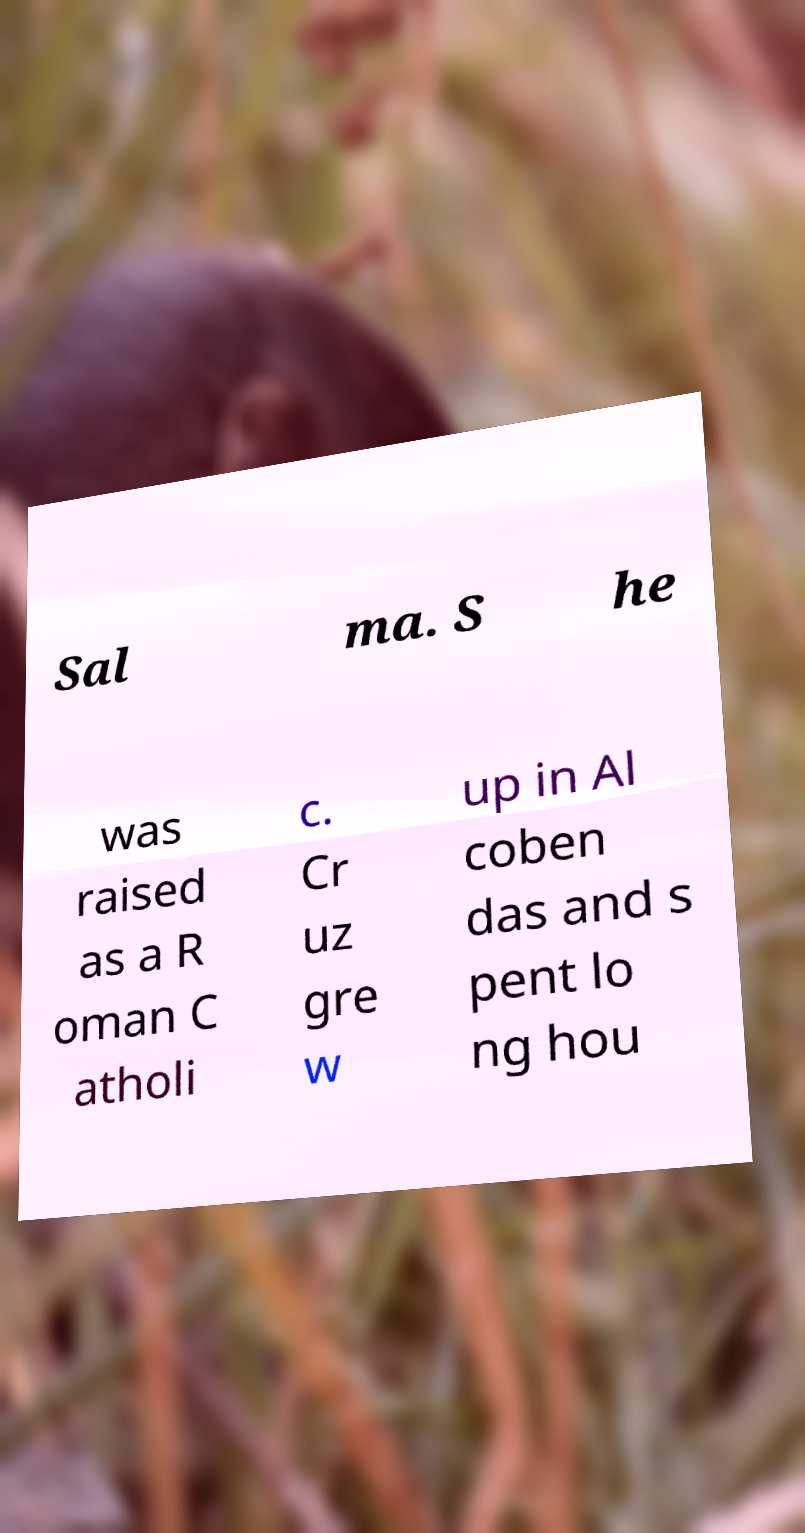For documentation purposes, I need the text within this image transcribed. Could you provide that? Sal ma. S he was raised as a R oman C atholi c. Cr uz gre w up in Al coben das and s pent lo ng hou 